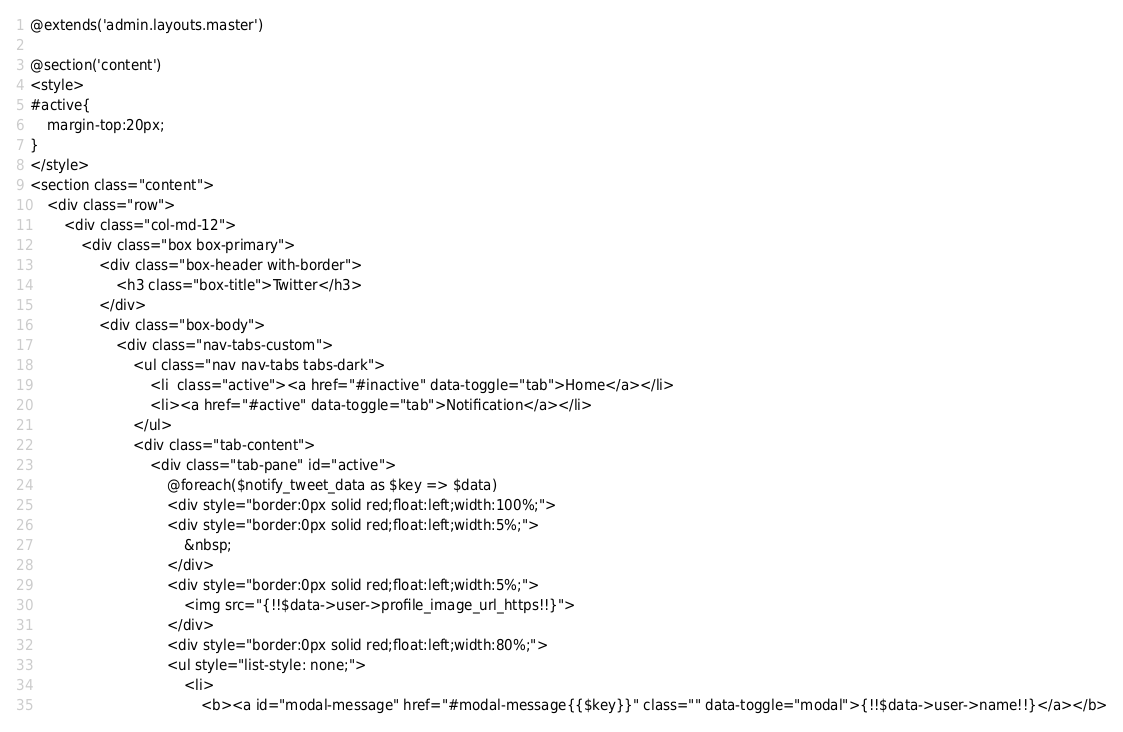<code> <loc_0><loc_0><loc_500><loc_500><_PHP_>@extends('admin.layouts.master')

@section('content')
<style>
#active{
	margin-top:20px;
}
</style>
<section class="content">
	<div class="row">
		<div class="col-md-12">
			<div class="box box-primary">
				<div class="box-header with-border">
					<h3 class="box-title">Twitter</h3>
				</div>
				<div class="box-body">
					<div class="nav-tabs-custom">
						<ul class="nav nav-tabs tabs-dark">
							<li  class="active"><a href="#inactive" data-toggle="tab">Home</a></li>
							<li><a href="#active" data-toggle="tab">Notification</a></li>
						</ul>
						<div class="tab-content">
							<div class="tab-pane" id="active">
								@foreach($notify_tweet_data as $key => $data)
								<div style="border:0px solid red;float:left;width:100%;">
								<div style="border:0px solid red;float:left;width:5%;">
									&nbsp;
								</div>
								<div style="border:0px solid red;float:left;width:5%;">
									<img src="{!!$data->user->profile_image_url_https!!}">
								</div>
								<div style="border:0px solid red;float:left;width:80%;">
								<ul style="list-style: none;">
									<li>
										<b><a id="modal-message" href="#modal-message{{$key}}" class="" data-toggle="modal">{!!$data->user->name!!}</a></b>
</code> 